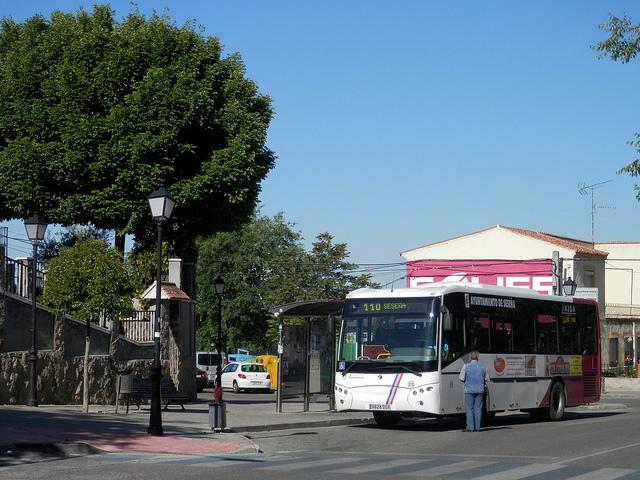What color is the bus?
Write a very short answer. White. What number is listed on top of the bus in front of the bus stop?
Quick response, please. 110. How many buses are there?
Keep it brief. 1. Do the trees have leaves?
Quick response, please. Yes. What is the yellow object used for?
Write a very short answer. Transportation. Where is the woman?
Short answer required. By bus. Does it look like autumn?
Short answer required. No. Is the bus moving?
Write a very short answer. No. Is the sky clear or cloudy?
Keep it brief. Clear. Is there a white car in the background?
Quick response, please. Yes. How many levels does the bus have?
Answer briefly. 1. How many stripes are crossing the street?
Concise answer only. 6. Which is taller, the woman or tree?
Concise answer only. Tree. What color is the trolley?
Quick response, please. White. What does the pink and white tent say on the right?
Keep it brief. Saves. How many levels does this bus have?
Short answer required. 1. Is it night time?
Short answer required. No. Is the picture blurry?
Give a very brief answer. No. What color is the man on the left wearing to make sure he doesn't get hit by a bus?
Short answer required. Blue. Is the bus new?
Keep it brief. Yes. How buses are there?
Quick response, please. 1. Is the bus red?
Short answer required. No. What kind of weather it is?
Keep it brief. Sunny. Is it Christmas time?
Be succinct. No. What establishment is the bus entering?
Be succinct. Bus stop. What type of buses are in the photo?
Concise answer only. City. What type of building is the bus in front of?
Short answer required. White. Is the bus driving toward us?
Quick response, please. Yes. Is there a tourist bus in the image?
Write a very short answer. Yes. Is that a bus?
Keep it brief. Yes. How many buses?
Answer briefly. 1. What is the letter and number on the bus sign?
Write a very short answer. 110. Is the bus in motion?
Be succinct. No. 